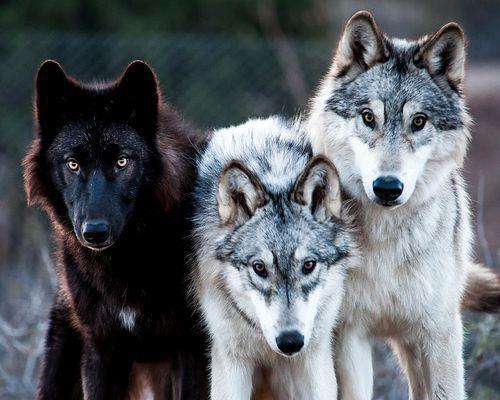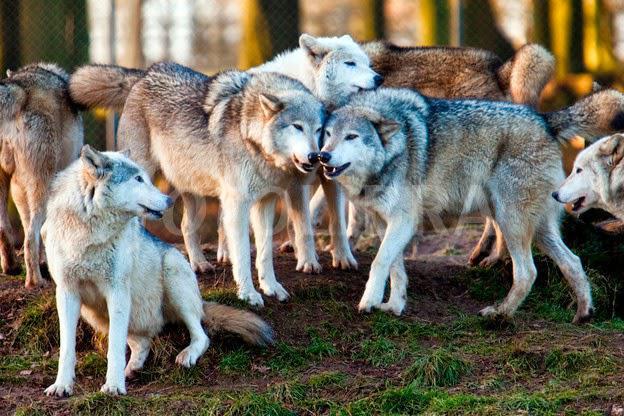The first image is the image on the left, the second image is the image on the right. Examine the images to the left and right. Is the description "There is at least one image where there are five or more wolves." accurate? Answer yes or no. Yes. The first image is the image on the left, the second image is the image on the right. For the images shown, is this caption "There is a black wolf on the left side of the image." true? Answer yes or no. Yes. 